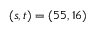Convert formula to latex. <formula><loc_0><loc_0><loc_500><loc_500>( s , t ) = ( 5 5 , 1 6 )</formula> 